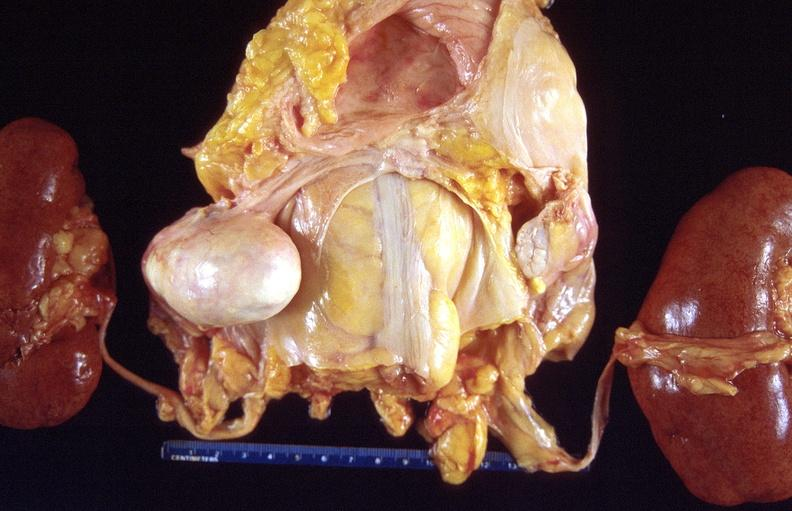does rheumatoid arthritis show dermoid cyst?
Answer the question using a single word or phrase. No 